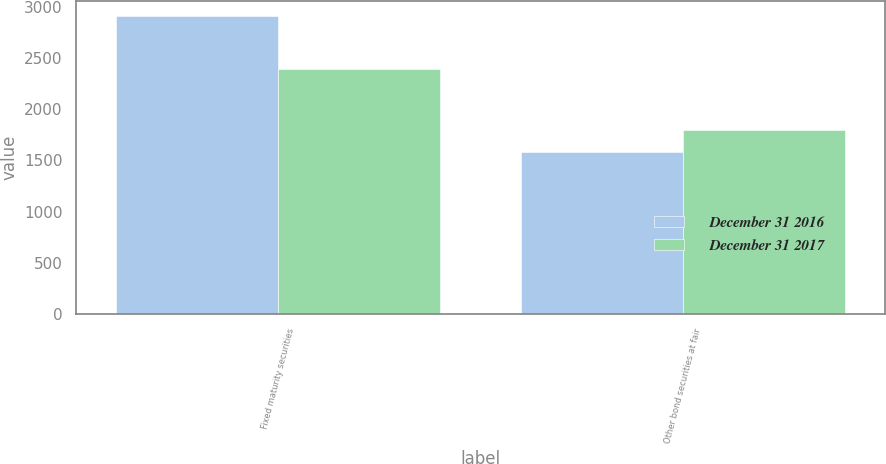<chart> <loc_0><loc_0><loc_500><loc_500><stacked_bar_chart><ecel><fcel>Fixed maturity securities<fcel>Other bond securities at fair<nl><fcel>December 31 2016<fcel>2911<fcel>1585<nl><fcel>December 31 2017<fcel>2389<fcel>1799<nl></chart> 